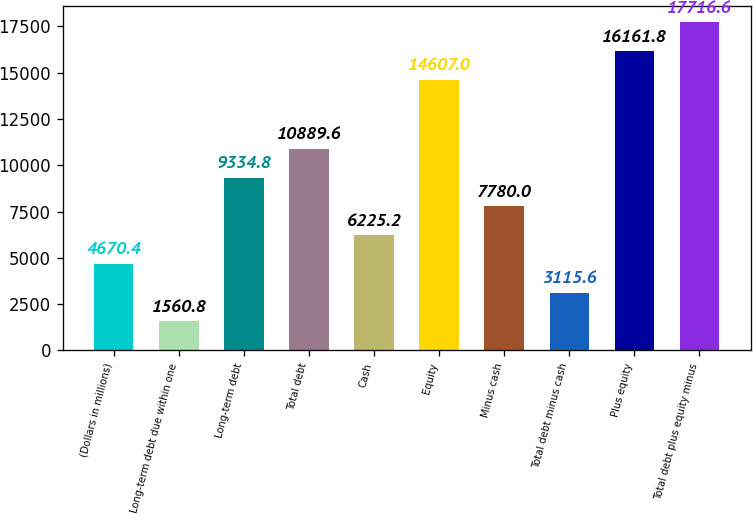Convert chart to OTSL. <chart><loc_0><loc_0><loc_500><loc_500><bar_chart><fcel>(Dollars in millions)<fcel>Long-term debt due within one<fcel>Long-term debt<fcel>Total debt<fcel>Cash<fcel>Equity<fcel>Minus cash<fcel>Total debt minus cash<fcel>Plus equity<fcel>Total debt plus equity minus<nl><fcel>4670.4<fcel>1560.8<fcel>9334.8<fcel>10889.6<fcel>6225.2<fcel>14607<fcel>7780<fcel>3115.6<fcel>16161.8<fcel>17716.6<nl></chart> 